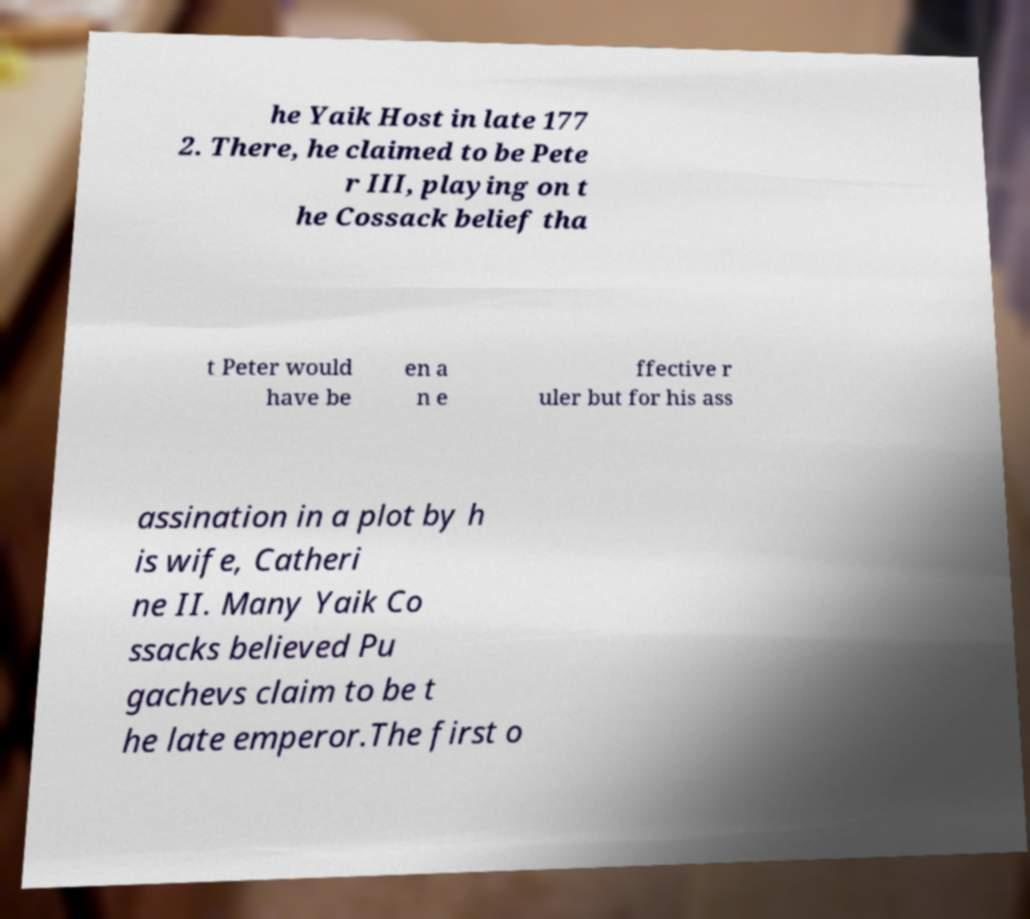Could you extract and type out the text from this image? he Yaik Host in late 177 2. There, he claimed to be Pete r III, playing on t he Cossack belief tha t Peter would have be en a n e ffective r uler but for his ass assination in a plot by h is wife, Catheri ne II. Many Yaik Co ssacks believed Pu gachevs claim to be t he late emperor.The first o 